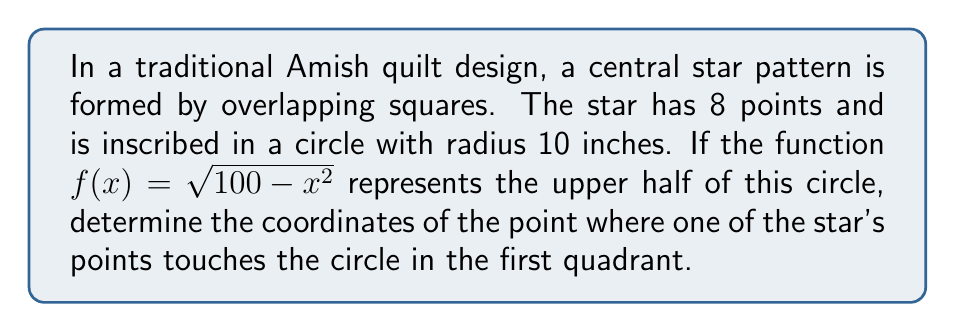Teach me how to tackle this problem. Let's approach this step-by-step:

1) The circle is centered at the origin (0,0) with a radius of 10 inches. Its equation is $x^2 + y^2 = 100$.

2) The function $f(x) = \sqrt{100 - x^2}$ represents the upper half of this circle.

3) An 8-pointed star has points at every 45° (360° / 8 = 45°).

4) In the first quadrant, the star point will touch the circle at a 45° angle from the positive x-axis.

5) For a 45° angle in a unit circle, x and y coordinates are equal. In our circle with radius 10, this point will have equal x and y coordinates.

6) Let's call this coordinate (a, a). It satisfies the circle equation:
   $a^2 + a^2 = 100$
   $2a^2 = 100$
   $a^2 = 50$
   $a = \sqrt{50} = 5\sqrt{2}$

7) We can verify this using our function:
   $f(5\sqrt{2}) = \sqrt{100 - (5\sqrt{2})^2} = \sqrt{100 - 50} = \sqrt{50} = 5\sqrt{2}$

Therefore, the point where the star touches the circle in the first quadrant is $(5\sqrt{2}, 5\sqrt{2})$.
Answer: $(5\sqrt{2}, 5\sqrt{2})$ 